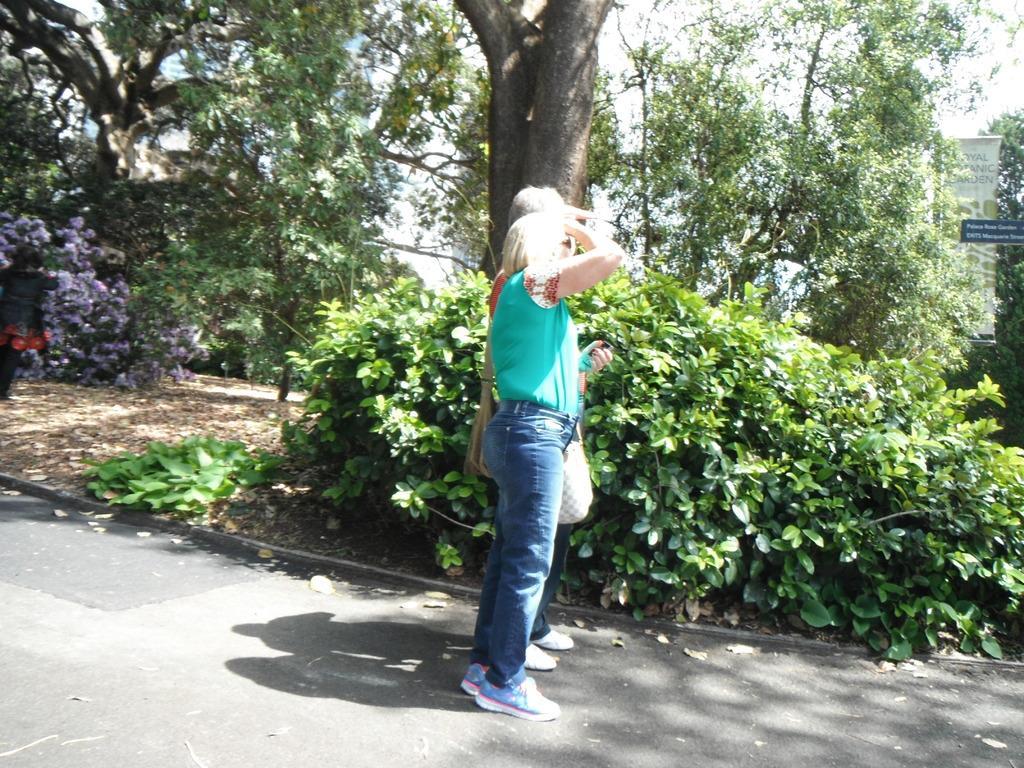Can you describe this image briefly? In this image, I can see two persons standing on a pathway and there are trees and plants. On the right side of the image, I can see the boards. In the background there is the sky. 